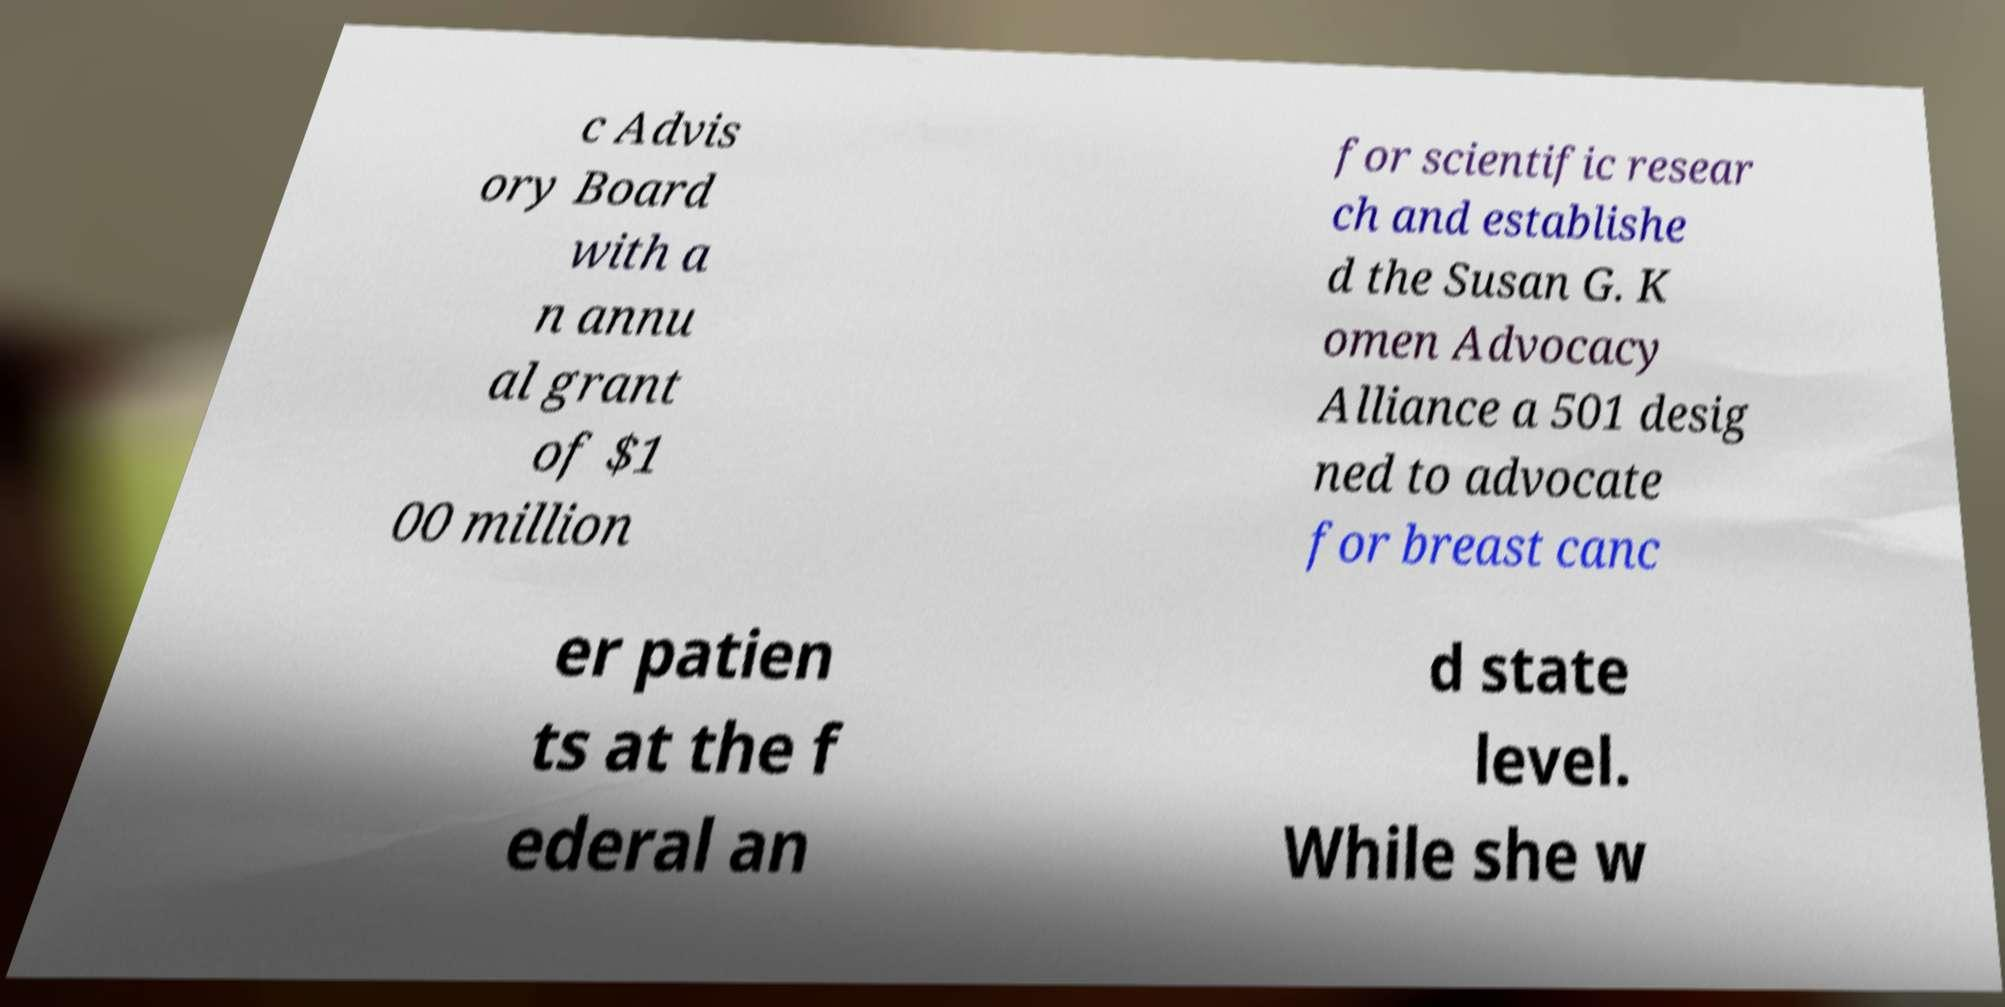For documentation purposes, I need the text within this image transcribed. Could you provide that? c Advis ory Board with a n annu al grant of $1 00 million for scientific resear ch and establishe d the Susan G. K omen Advocacy Alliance a 501 desig ned to advocate for breast canc er patien ts at the f ederal an d state level. While she w 